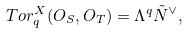Convert formula to latex. <formula><loc_0><loc_0><loc_500><loc_500>T o r _ { q } ^ { X } ( O _ { S } , O _ { T } ) = \Lambda ^ { q } \tilde { N } ^ { \vee } ,</formula> 